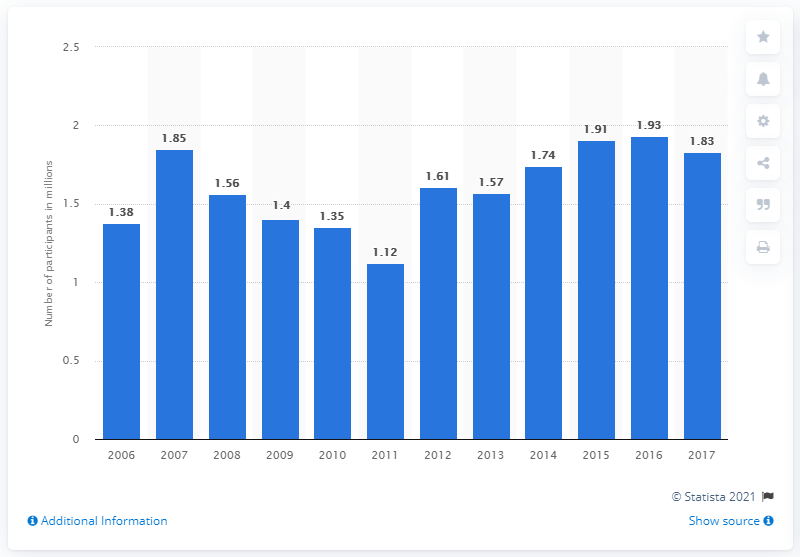Give some essential details in this illustration. In 2017, the total number of participants in roller hockey was 1.83.. 